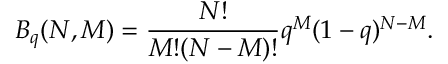<formula> <loc_0><loc_0><loc_500><loc_500>B _ { q } ( N , M ) = \frac { N ! } { M ! ( N - M ) ! } q ^ { M } ( 1 - q ) ^ { N - M } .</formula> 